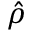<formula> <loc_0><loc_0><loc_500><loc_500>\hat { \rho }</formula> 